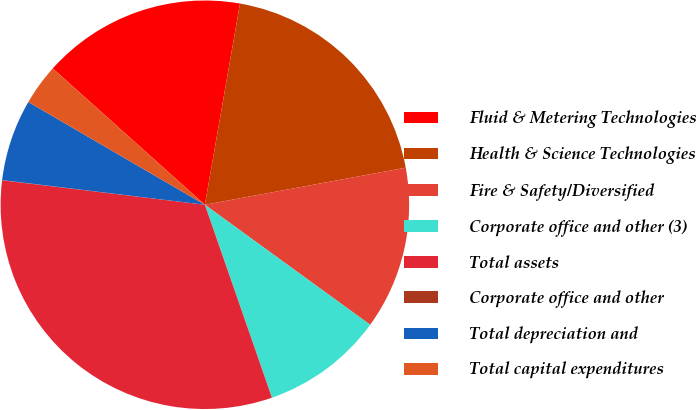Convert chart to OTSL. <chart><loc_0><loc_0><loc_500><loc_500><pie_chart><fcel>Fluid & Metering Technologies<fcel>Health & Science Technologies<fcel>Fire & Safety/Diversified<fcel>Corporate office and other (3)<fcel>Total assets<fcel>Corporate office and other<fcel>Total depreciation and<fcel>Total capital expenditures<nl><fcel>16.12%<fcel>19.34%<fcel>12.9%<fcel>9.68%<fcel>32.23%<fcel>0.02%<fcel>6.46%<fcel>3.24%<nl></chart> 